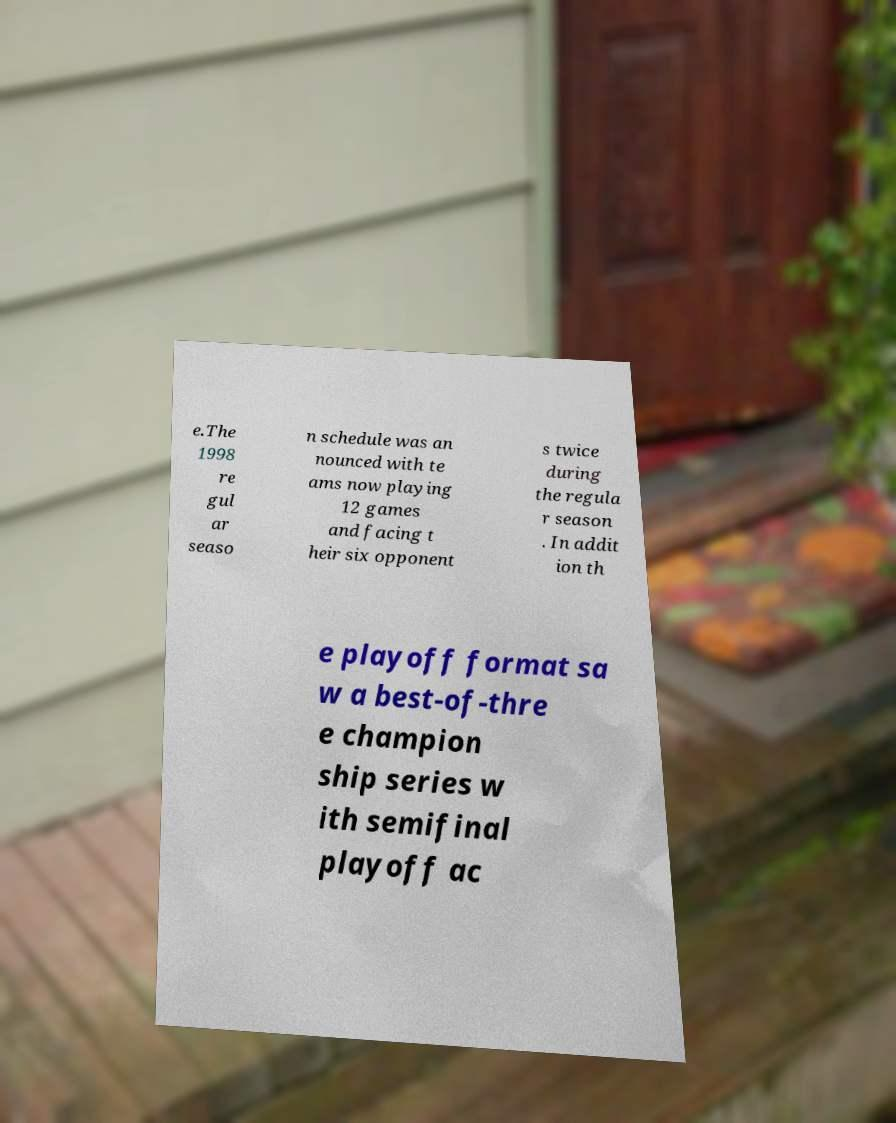Can you read and provide the text displayed in the image?This photo seems to have some interesting text. Can you extract and type it out for me? e.The 1998 re gul ar seaso n schedule was an nounced with te ams now playing 12 games and facing t heir six opponent s twice during the regula r season . In addit ion th e playoff format sa w a best-of-thre e champion ship series w ith semifinal playoff ac 